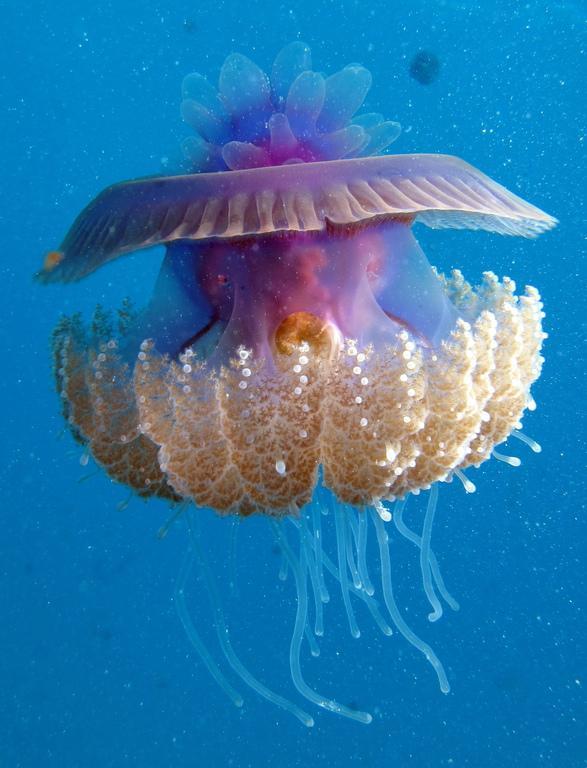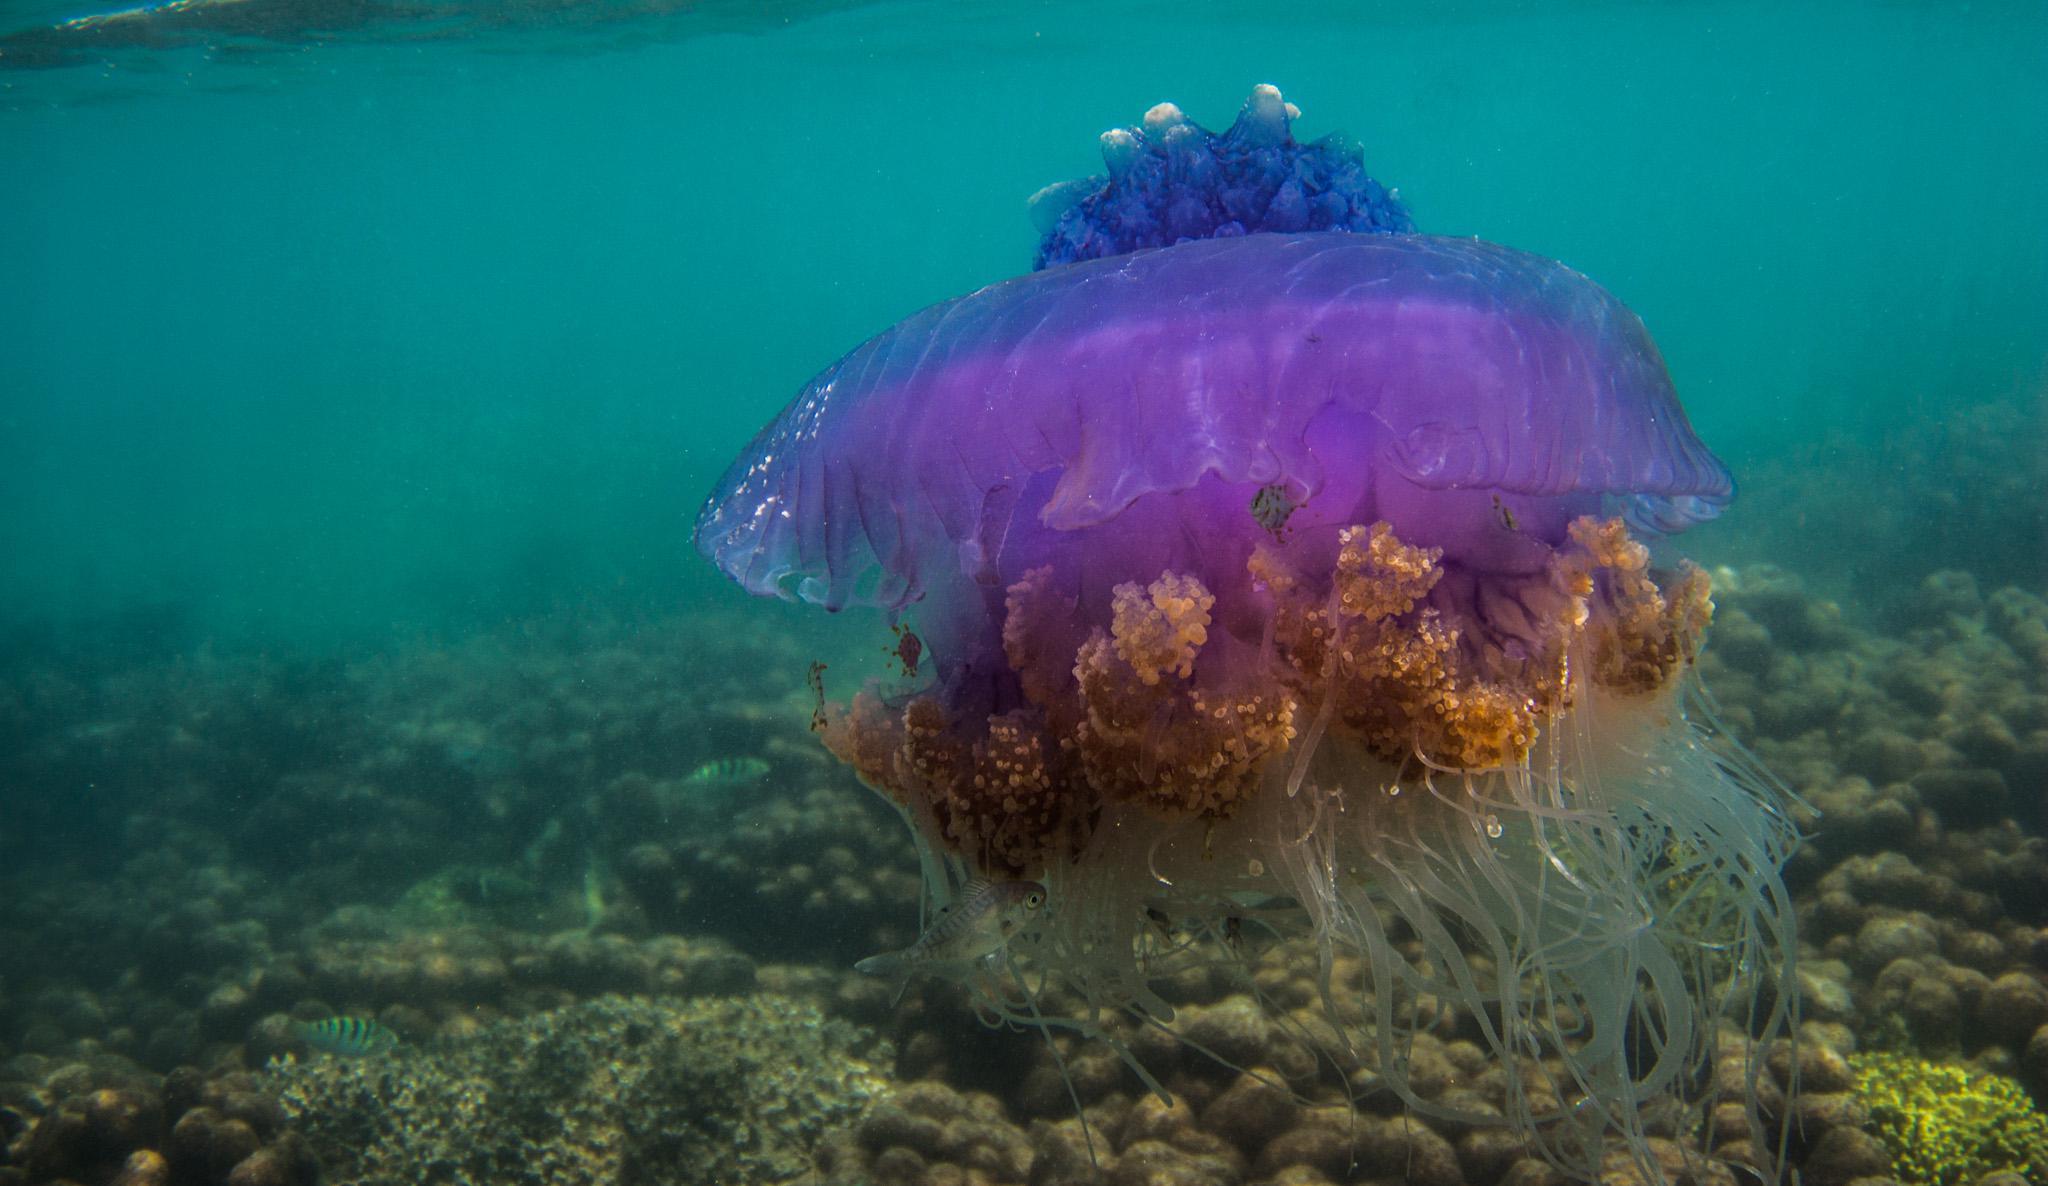The first image is the image on the left, the second image is the image on the right. Evaluate the accuracy of this statement regarding the images: "There are at least two small fish swimming near the jellyfish in one of the images.". Is it true? Answer yes or no. No. 